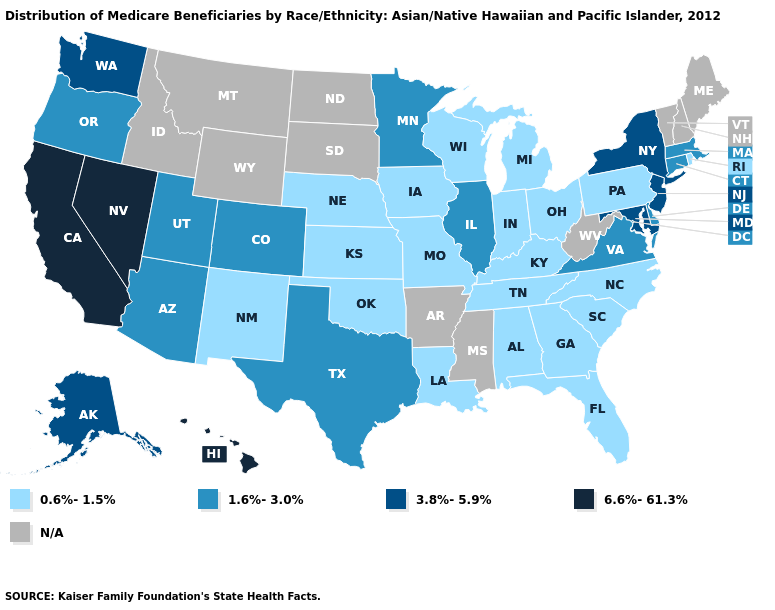Name the states that have a value in the range 6.6%-61.3%?
Quick response, please. California, Hawaii, Nevada. What is the value of Maryland?
Write a very short answer. 3.8%-5.9%. What is the value of Montana?
Keep it brief. N/A. What is the value of Louisiana?
Quick response, please. 0.6%-1.5%. Which states hav the highest value in the Northeast?
Answer briefly. New Jersey, New York. Which states hav the highest value in the West?
Concise answer only. California, Hawaii, Nevada. What is the value of Colorado?
Be succinct. 1.6%-3.0%. Among the states that border Nevada , does California have the lowest value?
Concise answer only. No. What is the lowest value in the West?
Write a very short answer. 0.6%-1.5%. What is the highest value in the Northeast ?
Be succinct. 3.8%-5.9%. What is the lowest value in the USA?
Short answer required. 0.6%-1.5%. What is the lowest value in states that border Illinois?
Answer briefly. 0.6%-1.5%. Does Connecticut have the lowest value in the USA?
Write a very short answer. No. What is the value of Maryland?
Short answer required. 3.8%-5.9%. 